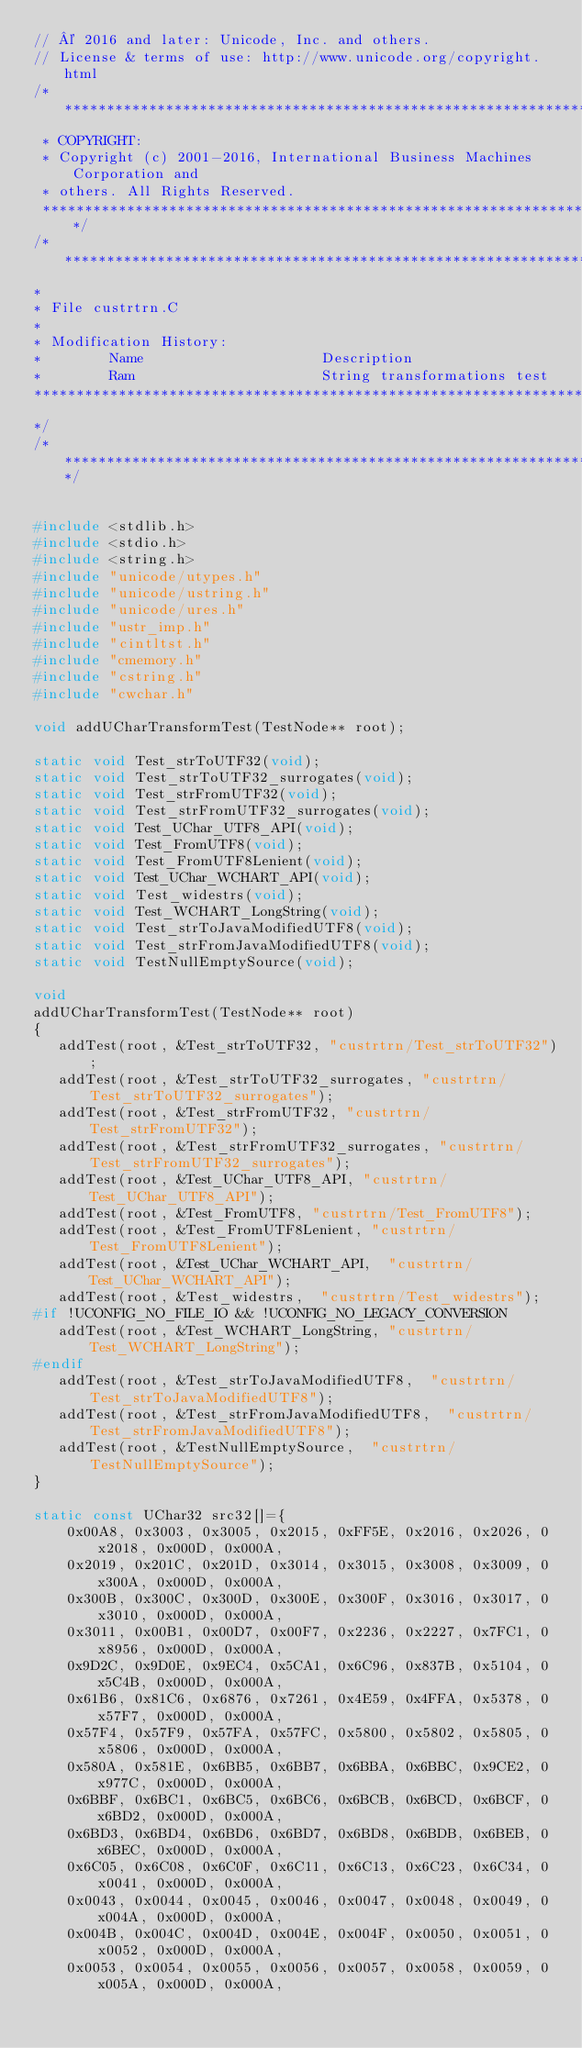Convert code to text. <code><loc_0><loc_0><loc_500><loc_500><_C_>// © 2016 and later: Unicode, Inc. and others.
// License & terms of use: http://www.unicode.org/copyright.html
/********************************************************************
 * COPYRIGHT:
 * Copyright (c) 2001-2016, International Business Machines Corporation and
 * others. All Rights Reserved.
 ********************************************************************/
/********************************************************************************
*
* File custrtrn.C
*
* Modification History:
*        Name                     Description
*        Ram                      String transformations test
*********************************************************************************
*/
/****************************************************************************/


#include <stdlib.h>
#include <stdio.h>
#include <string.h>
#include "unicode/utypes.h"
#include "unicode/ustring.h"
#include "unicode/ures.h"
#include "ustr_imp.h"
#include "cintltst.h"
#include "cmemory.h"
#include "cstring.h"
#include "cwchar.h"

void addUCharTransformTest(TestNode** root);

static void Test_strToUTF32(void);
static void Test_strToUTF32_surrogates(void);
static void Test_strFromUTF32(void);
static void Test_strFromUTF32_surrogates(void);
static void Test_UChar_UTF8_API(void);
static void Test_FromUTF8(void);
static void Test_FromUTF8Lenient(void);
static void Test_UChar_WCHART_API(void);
static void Test_widestrs(void);
static void Test_WCHART_LongString(void);
static void Test_strToJavaModifiedUTF8(void);
static void Test_strFromJavaModifiedUTF8(void);
static void TestNullEmptySource(void);

void 
addUCharTransformTest(TestNode** root)
{
   addTest(root, &Test_strToUTF32, "custrtrn/Test_strToUTF32");
   addTest(root, &Test_strToUTF32_surrogates, "custrtrn/Test_strToUTF32_surrogates");
   addTest(root, &Test_strFromUTF32, "custrtrn/Test_strFromUTF32");
   addTest(root, &Test_strFromUTF32_surrogates, "custrtrn/Test_strFromUTF32_surrogates");
   addTest(root, &Test_UChar_UTF8_API, "custrtrn/Test_UChar_UTF8_API");
   addTest(root, &Test_FromUTF8, "custrtrn/Test_FromUTF8");
   addTest(root, &Test_FromUTF8Lenient, "custrtrn/Test_FromUTF8Lenient");
   addTest(root, &Test_UChar_WCHART_API,  "custrtrn/Test_UChar_WCHART_API");
   addTest(root, &Test_widestrs,  "custrtrn/Test_widestrs");
#if !UCONFIG_NO_FILE_IO && !UCONFIG_NO_LEGACY_CONVERSION
   addTest(root, &Test_WCHART_LongString, "custrtrn/Test_WCHART_LongString");
#endif
   addTest(root, &Test_strToJavaModifiedUTF8,  "custrtrn/Test_strToJavaModifiedUTF8");
   addTest(root, &Test_strFromJavaModifiedUTF8,  "custrtrn/Test_strFromJavaModifiedUTF8");
   addTest(root, &TestNullEmptySource,  "custrtrn/TestNullEmptySource");
}

static const UChar32 src32[]={
    0x00A8, 0x3003, 0x3005, 0x2015, 0xFF5E, 0x2016, 0x2026, 0x2018, 0x000D, 0x000A,
    0x2019, 0x201C, 0x201D, 0x3014, 0x3015, 0x3008, 0x3009, 0x300A, 0x000D, 0x000A,
    0x300B, 0x300C, 0x300D, 0x300E, 0x300F, 0x3016, 0x3017, 0x3010, 0x000D, 0x000A,
    0x3011, 0x00B1, 0x00D7, 0x00F7, 0x2236, 0x2227, 0x7FC1, 0x8956, 0x000D, 0x000A,
    0x9D2C, 0x9D0E, 0x9EC4, 0x5CA1, 0x6C96, 0x837B, 0x5104, 0x5C4B, 0x000D, 0x000A,
    0x61B6, 0x81C6, 0x6876, 0x7261, 0x4E59, 0x4FFA, 0x5378, 0x57F7, 0x000D, 0x000A,
    0x57F4, 0x57F9, 0x57FA, 0x57FC, 0x5800, 0x5802, 0x5805, 0x5806, 0x000D, 0x000A,
    0x580A, 0x581E, 0x6BB5, 0x6BB7, 0x6BBA, 0x6BBC, 0x9CE2, 0x977C, 0x000D, 0x000A,
    0x6BBF, 0x6BC1, 0x6BC5, 0x6BC6, 0x6BCB, 0x6BCD, 0x6BCF, 0x6BD2, 0x000D, 0x000A,
    0x6BD3, 0x6BD4, 0x6BD6, 0x6BD7, 0x6BD8, 0x6BDB, 0x6BEB, 0x6BEC, 0x000D, 0x000A,
    0x6C05, 0x6C08, 0x6C0F, 0x6C11, 0x6C13, 0x6C23, 0x6C34, 0x0041, 0x000D, 0x000A,
    0x0043, 0x0044, 0x0045, 0x0046, 0x0047, 0x0048, 0x0049, 0x004A, 0x000D, 0x000A,
    0x004B, 0x004C, 0x004D, 0x004E, 0x004F, 0x0050, 0x0051, 0x0052, 0x000D, 0x000A,
    0x0053, 0x0054, 0x0055, 0x0056, 0x0057, 0x0058, 0x0059, 0x005A, 0x000D, 0x000A,</code> 